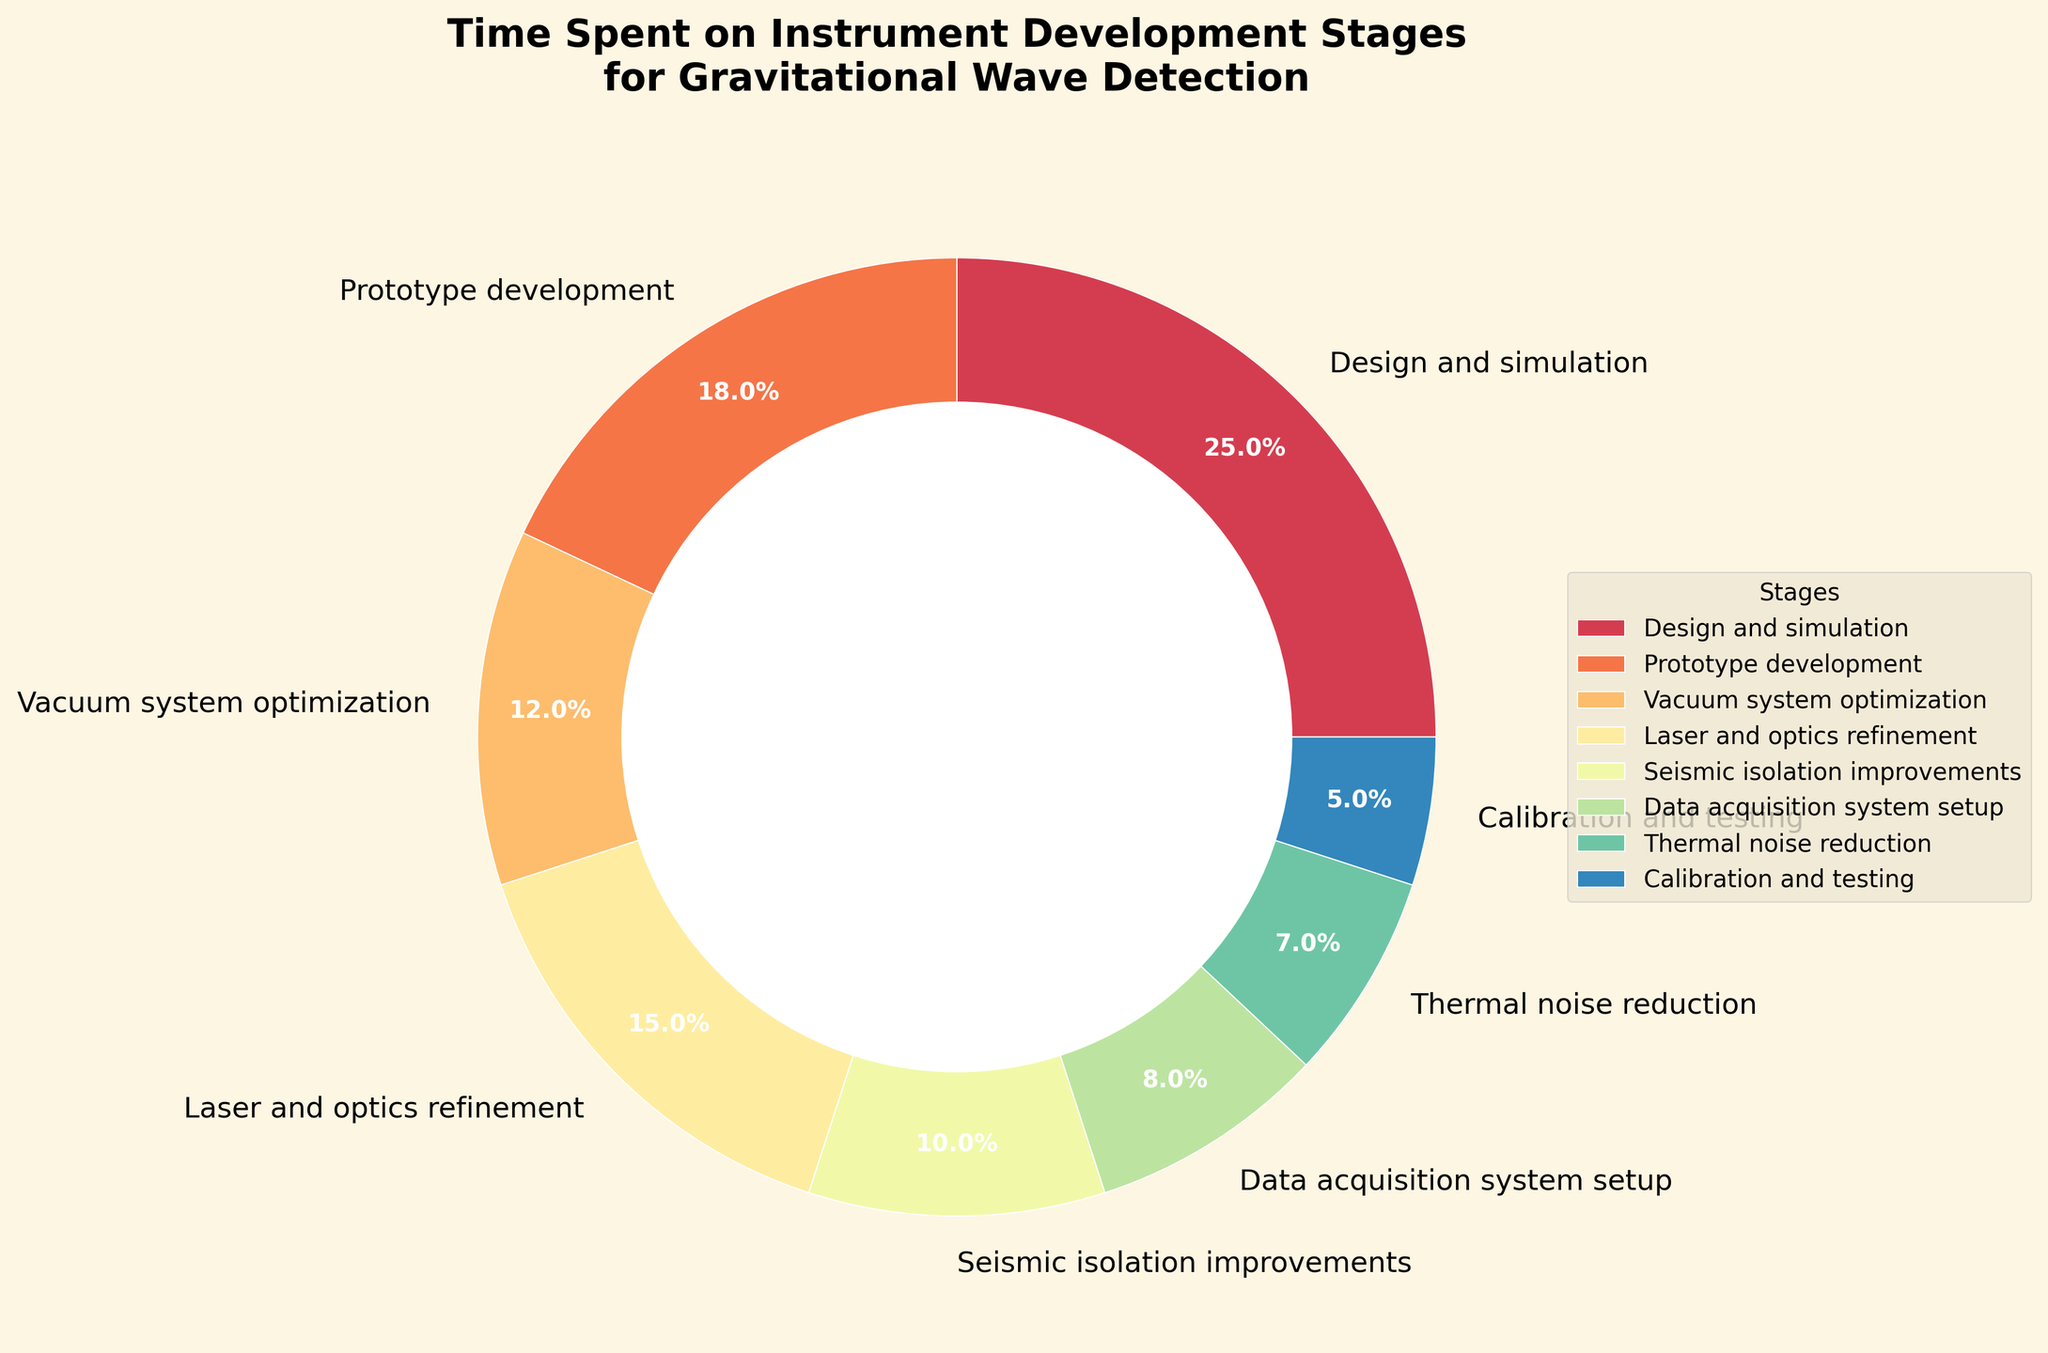Which stage takes up the largest percentage of time? By looking at the pie chart, we see that the section labeled "Design and simulation" is the largest.
Answer: Design and simulation Which two stages combined make up 30% of the time spent? "Laser and optics refinement" (15%) and "Seismic isolation improvements" (10%) together sum to 25%, so they need to be combined with another stage. Adding "Calibration and testing" (5%) makes the total 30%.
Answer: Laser and optics refinement and Seismic isolation improvements and Calibration and testing How much more time is spent on Design and simulation compared to Thermal noise reduction? "Design and simulation" takes up 25% and "Thermal noise reduction" takes up 7%. The difference is 25% - 7% = 18%.
Answer: 18% Which stages take up the same amount of time? Checking the chart, no stages have equal percentages. Each stage has a unique time allocation.
Answer: None What percentage of time is spent on stages related to noise management (Seismic isolation improvements and Thermal noise reduction)? "Seismic isolation improvements" is 10% and "Thermal noise reduction" is 7%. The total is 10% + 7% = 17%.
Answer: 17% Which stage takes up less than 10% of the time spent? The following stages have less than 10%: "Data acquisition system setup" (8%), "Thermal noise reduction" (7%), and "Calibration and testing" (5%).
Answer: Data acquisition system setup, Thermal noise reduction, Calibration and testing Is more time spent on Laser and optics refinement or Prototype development? "Laser and optics refinement" takes up 15% and "Prototype development" takes up 18%. So, more time is spent on Prototype development.
Answer: Prototype development How does the time spent on Vacuum system optimization compare with Data acquisition system setup? "Vacuum system optimization" takes up 12% while "Data acquisition system setup" takes up 8%. So, Vacuum system optimization takes 4% more time.
Answer: Vacuum system optimization takes 4% more What is the total percentage of time spent on Design and simulation, and Calibration and testing? "Design and simulation" is 25% and "Calibration and testing" is 5%. The total is 25% + 5% = 30%.
Answer: 30% What percentage of time is spent on Design and simulation, Prototype development, and Vacuum system optimization combined? "Design and simulation" is 25%, "Prototype development" is 18%, and "Vacuum system optimization" is 12%. The total is 25% + 18% + 12% = 55%.
Answer: 55% 